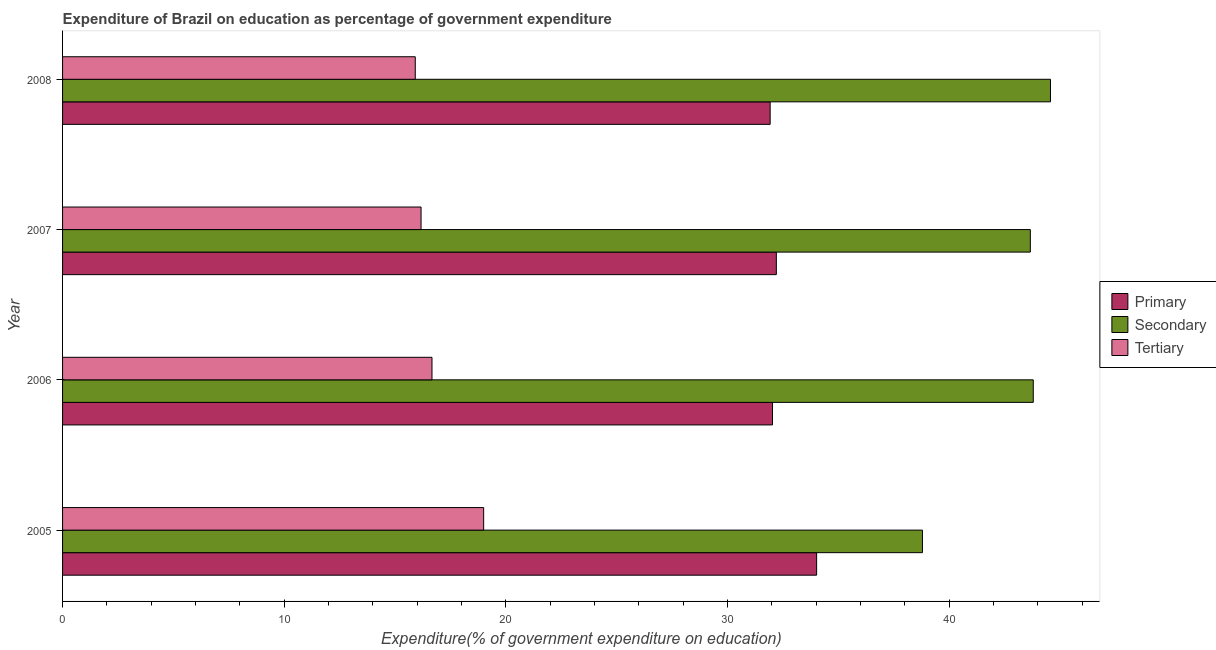Are the number of bars per tick equal to the number of legend labels?
Offer a very short reply. Yes. Are the number of bars on each tick of the Y-axis equal?
Your answer should be very brief. Yes. How many bars are there on the 4th tick from the bottom?
Your response must be concise. 3. What is the label of the 4th group of bars from the top?
Ensure brevity in your answer.  2005. In how many cases, is the number of bars for a given year not equal to the number of legend labels?
Your response must be concise. 0. What is the expenditure on tertiary education in 2007?
Keep it short and to the point. 16.17. Across all years, what is the maximum expenditure on tertiary education?
Offer a terse response. 19. Across all years, what is the minimum expenditure on tertiary education?
Ensure brevity in your answer.  15.91. In which year was the expenditure on tertiary education minimum?
Offer a very short reply. 2008. What is the total expenditure on secondary education in the graph?
Ensure brevity in your answer.  170.8. What is the difference between the expenditure on secondary education in 2006 and that in 2008?
Give a very brief answer. -0.78. What is the difference between the expenditure on primary education in 2008 and the expenditure on tertiary education in 2005?
Ensure brevity in your answer.  12.92. What is the average expenditure on primary education per year?
Give a very brief answer. 32.54. In the year 2008, what is the difference between the expenditure on tertiary education and expenditure on primary education?
Offer a very short reply. -16.01. What is the ratio of the expenditure on secondary education in 2007 to that in 2008?
Offer a terse response. 0.98. Is the expenditure on tertiary education in 2006 less than that in 2008?
Your answer should be compact. No. Is the difference between the expenditure on secondary education in 2005 and 2006 greater than the difference between the expenditure on primary education in 2005 and 2006?
Keep it short and to the point. No. What is the difference between the highest and the second highest expenditure on tertiary education?
Make the answer very short. 2.33. What is the difference between the highest and the lowest expenditure on secondary education?
Your answer should be compact. 5.78. In how many years, is the expenditure on primary education greater than the average expenditure on primary education taken over all years?
Your answer should be very brief. 1. Is the sum of the expenditure on secondary education in 2005 and 2008 greater than the maximum expenditure on tertiary education across all years?
Offer a terse response. Yes. What does the 1st bar from the top in 2007 represents?
Provide a short and direct response. Tertiary. What does the 3rd bar from the bottom in 2007 represents?
Make the answer very short. Tertiary. How many bars are there?
Offer a terse response. 12. How many years are there in the graph?
Keep it short and to the point. 4. Are the values on the major ticks of X-axis written in scientific E-notation?
Make the answer very short. No. Does the graph contain any zero values?
Give a very brief answer. No. Does the graph contain grids?
Offer a very short reply. No. How many legend labels are there?
Give a very brief answer. 3. What is the title of the graph?
Make the answer very short. Expenditure of Brazil on education as percentage of government expenditure. Does "Social Protection" appear as one of the legend labels in the graph?
Offer a terse response. No. What is the label or title of the X-axis?
Provide a succinct answer. Expenditure(% of government expenditure on education). What is the label or title of the Y-axis?
Make the answer very short. Year. What is the Expenditure(% of government expenditure on education) of Primary in 2005?
Provide a short and direct response. 34.02. What is the Expenditure(% of government expenditure on education) in Secondary in 2005?
Your answer should be very brief. 38.79. What is the Expenditure(% of government expenditure on education) of Tertiary in 2005?
Ensure brevity in your answer.  19. What is the Expenditure(% of government expenditure on education) in Primary in 2006?
Your answer should be very brief. 32.02. What is the Expenditure(% of government expenditure on education) in Secondary in 2006?
Your answer should be compact. 43.79. What is the Expenditure(% of government expenditure on education) in Tertiary in 2006?
Provide a succinct answer. 16.66. What is the Expenditure(% of government expenditure on education) in Primary in 2007?
Offer a terse response. 32.2. What is the Expenditure(% of government expenditure on education) of Secondary in 2007?
Offer a very short reply. 43.66. What is the Expenditure(% of government expenditure on education) in Tertiary in 2007?
Give a very brief answer. 16.17. What is the Expenditure(% of government expenditure on education) in Primary in 2008?
Give a very brief answer. 31.92. What is the Expenditure(% of government expenditure on education) of Secondary in 2008?
Make the answer very short. 44.56. What is the Expenditure(% of government expenditure on education) in Tertiary in 2008?
Your answer should be compact. 15.91. Across all years, what is the maximum Expenditure(% of government expenditure on education) of Primary?
Your answer should be compact. 34.02. Across all years, what is the maximum Expenditure(% of government expenditure on education) in Secondary?
Make the answer very short. 44.56. Across all years, what is the maximum Expenditure(% of government expenditure on education) in Tertiary?
Make the answer very short. 19. Across all years, what is the minimum Expenditure(% of government expenditure on education) of Primary?
Offer a terse response. 31.92. Across all years, what is the minimum Expenditure(% of government expenditure on education) of Secondary?
Provide a short and direct response. 38.79. Across all years, what is the minimum Expenditure(% of government expenditure on education) of Tertiary?
Give a very brief answer. 15.91. What is the total Expenditure(% of government expenditure on education) in Primary in the graph?
Provide a short and direct response. 130.16. What is the total Expenditure(% of government expenditure on education) of Secondary in the graph?
Offer a terse response. 170.8. What is the total Expenditure(% of government expenditure on education) in Tertiary in the graph?
Provide a short and direct response. 67.74. What is the difference between the Expenditure(% of government expenditure on education) of Primary in 2005 and that in 2006?
Give a very brief answer. 1.99. What is the difference between the Expenditure(% of government expenditure on education) of Secondary in 2005 and that in 2006?
Provide a succinct answer. -5. What is the difference between the Expenditure(% of government expenditure on education) in Tertiary in 2005 and that in 2006?
Your answer should be very brief. 2.33. What is the difference between the Expenditure(% of government expenditure on education) in Primary in 2005 and that in 2007?
Offer a very short reply. 1.82. What is the difference between the Expenditure(% of government expenditure on education) of Secondary in 2005 and that in 2007?
Provide a short and direct response. -4.87. What is the difference between the Expenditure(% of government expenditure on education) in Tertiary in 2005 and that in 2007?
Provide a short and direct response. 2.82. What is the difference between the Expenditure(% of government expenditure on education) of Primary in 2005 and that in 2008?
Your response must be concise. 2.1. What is the difference between the Expenditure(% of government expenditure on education) of Secondary in 2005 and that in 2008?
Offer a terse response. -5.78. What is the difference between the Expenditure(% of government expenditure on education) of Tertiary in 2005 and that in 2008?
Your response must be concise. 3.08. What is the difference between the Expenditure(% of government expenditure on education) in Primary in 2006 and that in 2007?
Make the answer very short. -0.17. What is the difference between the Expenditure(% of government expenditure on education) in Secondary in 2006 and that in 2007?
Provide a succinct answer. 0.13. What is the difference between the Expenditure(% of government expenditure on education) of Tertiary in 2006 and that in 2007?
Keep it short and to the point. 0.49. What is the difference between the Expenditure(% of government expenditure on education) in Primary in 2006 and that in 2008?
Ensure brevity in your answer.  0.11. What is the difference between the Expenditure(% of government expenditure on education) of Secondary in 2006 and that in 2008?
Make the answer very short. -0.78. What is the difference between the Expenditure(% of government expenditure on education) in Tertiary in 2006 and that in 2008?
Your answer should be very brief. 0.75. What is the difference between the Expenditure(% of government expenditure on education) in Primary in 2007 and that in 2008?
Provide a short and direct response. 0.28. What is the difference between the Expenditure(% of government expenditure on education) in Secondary in 2007 and that in 2008?
Your answer should be compact. -0.91. What is the difference between the Expenditure(% of government expenditure on education) in Tertiary in 2007 and that in 2008?
Provide a succinct answer. 0.26. What is the difference between the Expenditure(% of government expenditure on education) in Primary in 2005 and the Expenditure(% of government expenditure on education) in Secondary in 2006?
Ensure brevity in your answer.  -9.77. What is the difference between the Expenditure(% of government expenditure on education) of Primary in 2005 and the Expenditure(% of government expenditure on education) of Tertiary in 2006?
Your answer should be compact. 17.35. What is the difference between the Expenditure(% of government expenditure on education) of Secondary in 2005 and the Expenditure(% of government expenditure on education) of Tertiary in 2006?
Keep it short and to the point. 22.12. What is the difference between the Expenditure(% of government expenditure on education) in Primary in 2005 and the Expenditure(% of government expenditure on education) in Secondary in 2007?
Your answer should be compact. -9.64. What is the difference between the Expenditure(% of government expenditure on education) of Primary in 2005 and the Expenditure(% of government expenditure on education) of Tertiary in 2007?
Your answer should be compact. 17.84. What is the difference between the Expenditure(% of government expenditure on education) in Secondary in 2005 and the Expenditure(% of government expenditure on education) in Tertiary in 2007?
Your answer should be very brief. 22.62. What is the difference between the Expenditure(% of government expenditure on education) in Primary in 2005 and the Expenditure(% of government expenditure on education) in Secondary in 2008?
Your response must be concise. -10.55. What is the difference between the Expenditure(% of government expenditure on education) of Primary in 2005 and the Expenditure(% of government expenditure on education) of Tertiary in 2008?
Your response must be concise. 18.11. What is the difference between the Expenditure(% of government expenditure on education) of Secondary in 2005 and the Expenditure(% of government expenditure on education) of Tertiary in 2008?
Your answer should be very brief. 22.88. What is the difference between the Expenditure(% of government expenditure on education) of Primary in 2006 and the Expenditure(% of government expenditure on education) of Secondary in 2007?
Make the answer very short. -11.63. What is the difference between the Expenditure(% of government expenditure on education) in Primary in 2006 and the Expenditure(% of government expenditure on education) in Tertiary in 2007?
Offer a very short reply. 15.85. What is the difference between the Expenditure(% of government expenditure on education) of Secondary in 2006 and the Expenditure(% of government expenditure on education) of Tertiary in 2007?
Give a very brief answer. 27.62. What is the difference between the Expenditure(% of government expenditure on education) of Primary in 2006 and the Expenditure(% of government expenditure on education) of Secondary in 2008?
Offer a very short reply. -12.54. What is the difference between the Expenditure(% of government expenditure on education) of Primary in 2006 and the Expenditure(% of government expenditure on education) of Tertiary in 2008?
Make the answer very short. 16.11. What is the difference between the Expenditure(% of government expenditure on education) of Secondary in 2006 and the Expenditure(% of government expenditure on education) of Tertiary in 2008?
Give a very brief answer. 27.88. What is the difference between the Expenditure(% of government expenditure on education) in Primary in 2007 and the Expenditure(% of government expenditure on education) in Secondary in 2008?
Your response must be concise. -12.37. What is the difference between the Expenditure(% of government expenditure on education) of Primary in 2007 and the Expenditure(% of government expenditure on education) of Tertiary in 2008?
Provide a succinct answer. 16.29. What is the difference between the Expenditure(% of government expenditure on education) in Secondary in 2007 and the Expenditure(% of government expenditure on education) in Tertiary in 2008?
Give a very brief answer. 27.75. What is the average Expenditure(% of government expenditure on education) in Primary per year?
Your answer should be compact. 32.54. What is the average Expenditure(% of government expenditure on education) in Secondary per year?
Keep it short and to the point. 42.7. What is the average Expenditure(% of government expenditure on education) of Tertiary per year?
Your answer should be very brief. 16.94. In the year 2005, what is the difference between the Expenditure(% of government expenditure on education) in Primary and Expenditure(% of government expenditure on education) in Secondary?
Keep it short and to the point. -4.77. In the year 2005, what is the difference between the Expenditure(% of government expenditure on education) in Primary and Expenditure(% of government expenditure on education) in Tertiary?
Ensure brevity in your answer.  15.02. In the year 2005, what is the difference between the Expenditure(% of government expenditure on education) in Secondary and Expenditure(% of government expenditure on education) in Tertiary?
Provide a short and direct response. 19.79. In the year 2006, what is the difference between the Expenditure(% of government expenditure on education) of Primary and Expenditure(% of government expenditure on education) of Secondary?
Offer a terse response. -11.76. In the year 2006, what is the difference between the Expenditure(% of government expenditure on education) in Primary and Expenditure(% of government expenditure on education) in Tertiary?
Provide a short and direct response. 15.36. In the year 2006, what is the difference between the Expenditure(% of government expenditure on education) in Secondary and Expenditure(% of government expenditure on education) in Tertiary?
Your response must be concise. 27.12. In the year 2007, what is the difference between the Expenditure(% of government expenditure on education) in Primary and Expenditure(% of government expenditure on education) in Secondary?
Your answer should be compact. -11.46. In the year 2007, what is the difference between the Expenditure(% of government expenditure on education) in Primary and Expenditure(% of government expenditure on education) in Tertiary?
Ensure brevity in your answer.  16.03. In the year 2007, what is the difference between the Expenditure(% of government expenditure on education) in Secondary and Expenditure(% of government expenditure on education) in Tertiary?
Provide a short and direct response. 27.48. In the year 2008, what is the difference between the Expenditure(% of government expenditure on education) of Primary and Expenditure(% of government expenditure on education) of Secondary?
Offer a terse response. -12.64. In the year 2008, what is the difference between the Expenditure(% of government expenditure on education) in Primary and Expenditure(% of government expenditure on education) in Tertiary?
Offer a terse response. 16.01. In the year 2008, what is the difference between the Expenditure(% of government expenditure on education) of Secondary and Expenditure(% of government expenditure on education) of Tertiary?
Your answer should be very brief. 28.65. What is the ratio of the Expenditure(% of government expenditure on education) in Primary in 2005 to that in 2006?
Ensure brevity in your answer.  1.06. What is the ratio of the Expenditure(% of government expenditure on education) of Secondary in 2005 to that in 2006?
Ensure brevity in your answer.  0.89. What is the ratio of the Expenditure(% of government expenditure on education) of Tertiary in 2005 to that in 2006?
Offer a very short reply. 1.14. What is the ratio of the Expenditure(% of government expenditure on education) in Primary in 2005 to that in 2007?
Give a very brief answer. 1.06. What is the ratio of the Expenditure(% of government expenditure on education) in Secondary in 2005 to that in 2007?
Your answer should be very brief. 0.89. What is the ratio of the Expenditure(% of government expenditure on education) of Tertiary in 2005 to that in 2007?
Your answer should be very brief. 1.17. What is the ratio of the Expenditure(% of government expenditure on education) of Primary in 2005 to that in 2008?
Your answer should be compact. 1.07. What is the ratio of the Expenditure(% of government expenditure on education) in Secondary in 2005 to that in 2008?
Make the answer very short. 0.87. What is the ratio of the Expenditure(% of government expenditure on education) of Tertiary in 2005 to that in 2008?
Your response must be concise. 1.19. What is the ratio of the Expenditure(% of government expenditure on education) of Tertiary in 2006 to that in 2007?
Your answer should be compact. 1.03. What is the ratio of the Expenditure(% of government expenditure on education) in Primary in 2006 to that in 2008?
Your response must be concise. 1. What is the ratio of the Expenditure(% of government expenditure on education) of Secondary in 2006 to that in 2008?
Offer a terse response. 0.98. What is the ratio of the Expenditure(% of government expenditure on education) of Tertiary in 2006 to that in 2008?
Your answer should be compact. 1.05. What is the ratio of the Expenditure(% of government expenditure on education) of Primary in 2007 to that in 2008?
Your answer should be compact. 1.01. What is the ratio of the Expenditure(% of government expenditure on education) of Secondary in 2007 to that in 2008?
Your answer should be very brief. 0.98. What is the ratio of the Expenditure(% of government expenditure on education) in Tertiary in 2007 to that in 2008?
Provide a short and direct response. 1.02. What is the difference between the highest and the second highest Expenditure(% of government expenditure on education) of Primary?
Offer a terse response. 1.82. What is the difference between the highest and the second highest Expenditure(% of government expenditure on education) of Secondary?
Provide a succinct answer. 0.78. What is the difference between the highest and the second highest Expenditure(% of government expenditure on education) in Tertiary?
Make the answer very short. 2.33. What is the difference between the highest and the lowest Expenditure(% of government expenditure on education) of Primary?
Provide a short and direct response. 2.1. What is the difference between the highest and the lowest Expenditure(% of government expenditure on education) in Secondary?
Provide a short and direct response. 5.78. What is the difference between the highest and the lowest Expenditure(% of government expenditure on education) of Tertiary?
Keep it short and to the point. 3.08. 